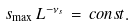Convert formula to latex. <formula><loc_0><loc_0><loc_500><loc_500>s _ { \max } \, L ^ { - { \nu _ { s } } } \, = \, c o n s t .</formula> 